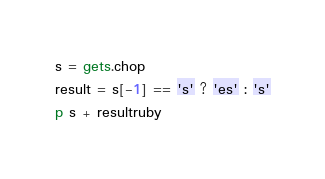Convert code to text. <code><loc_0><loc_0><loc_500><loc_500><_Ruby_>s = gets.chop
result = s[-1] == 's' ? 'es' : 's'
p s + resultruby</code> 